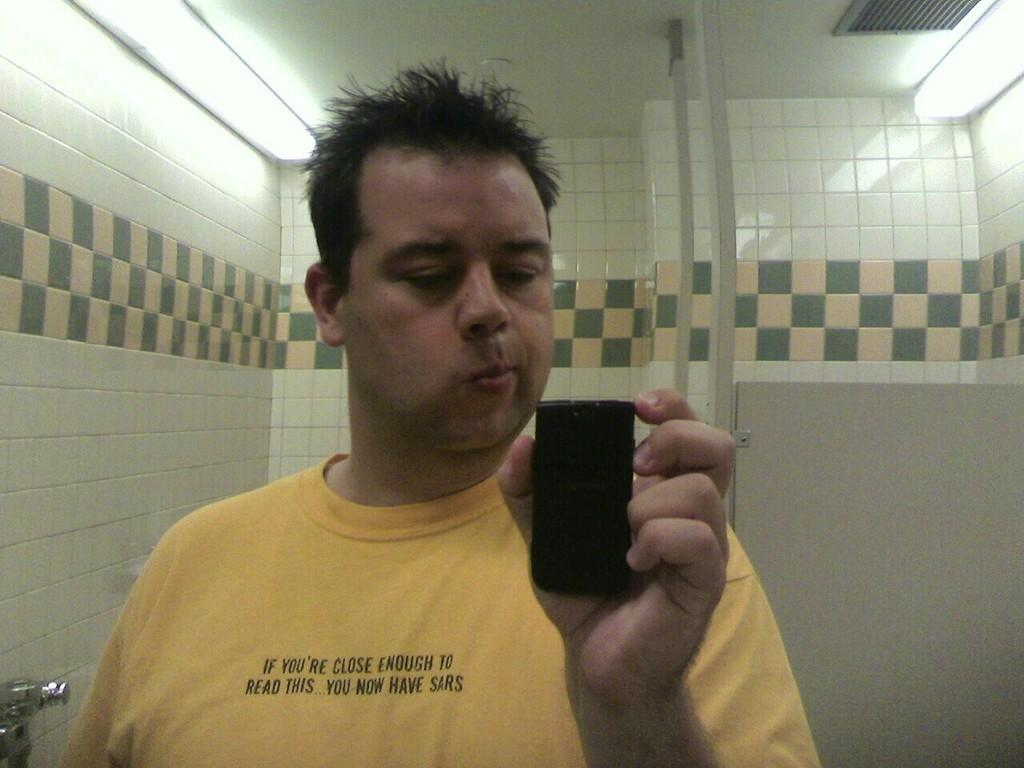What is the main subject in the foreground of the image? There is a person in the foreground of the image. What is the person holding in their hand? The person is holding an object in their hand. What can be seen in the background of the image? There is a wall and lights in the background of the image. Can you describe the setting of the image? The image may have been taken in a room, based on the presence of a wall and lights. Can you see any cobwebs in the image? There is no mention of cobwebs in the provided facts, so we cannot determine if any are present in the image. Is the person in the image about to take flight? There is no indication in the image that the person is about to take flight, as they are holding an object in their hand and standing in a room. 